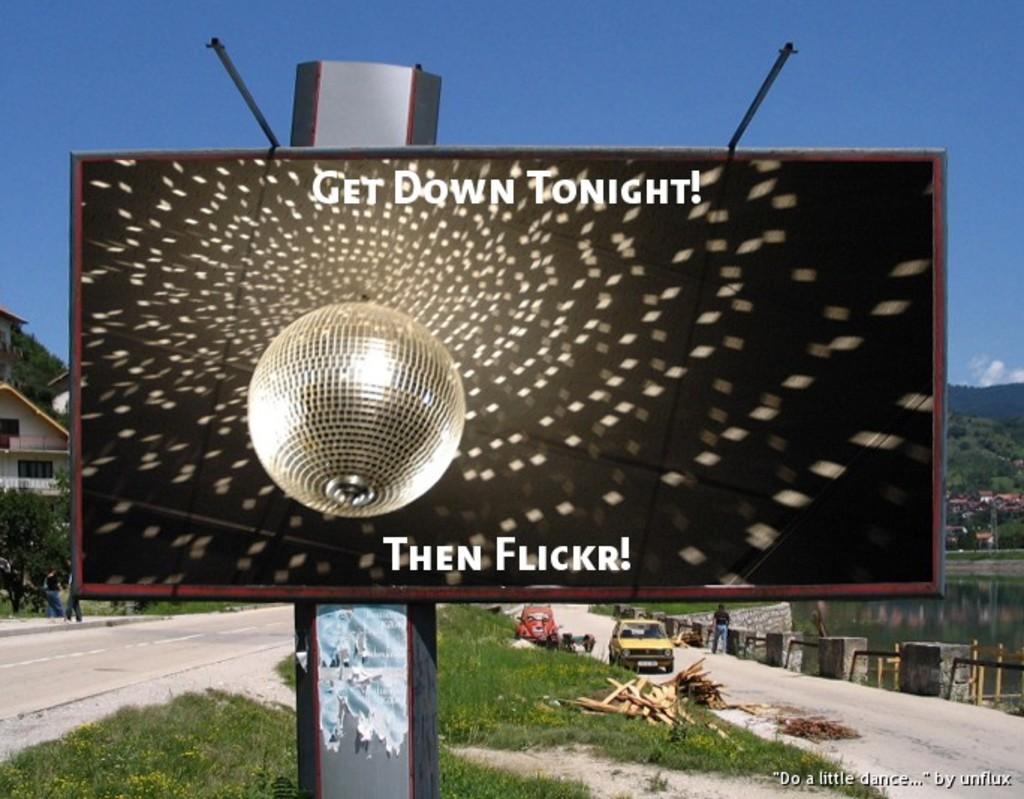What is the line on the bottom of the sign?
Provide a succinct answer. Then flickr. 